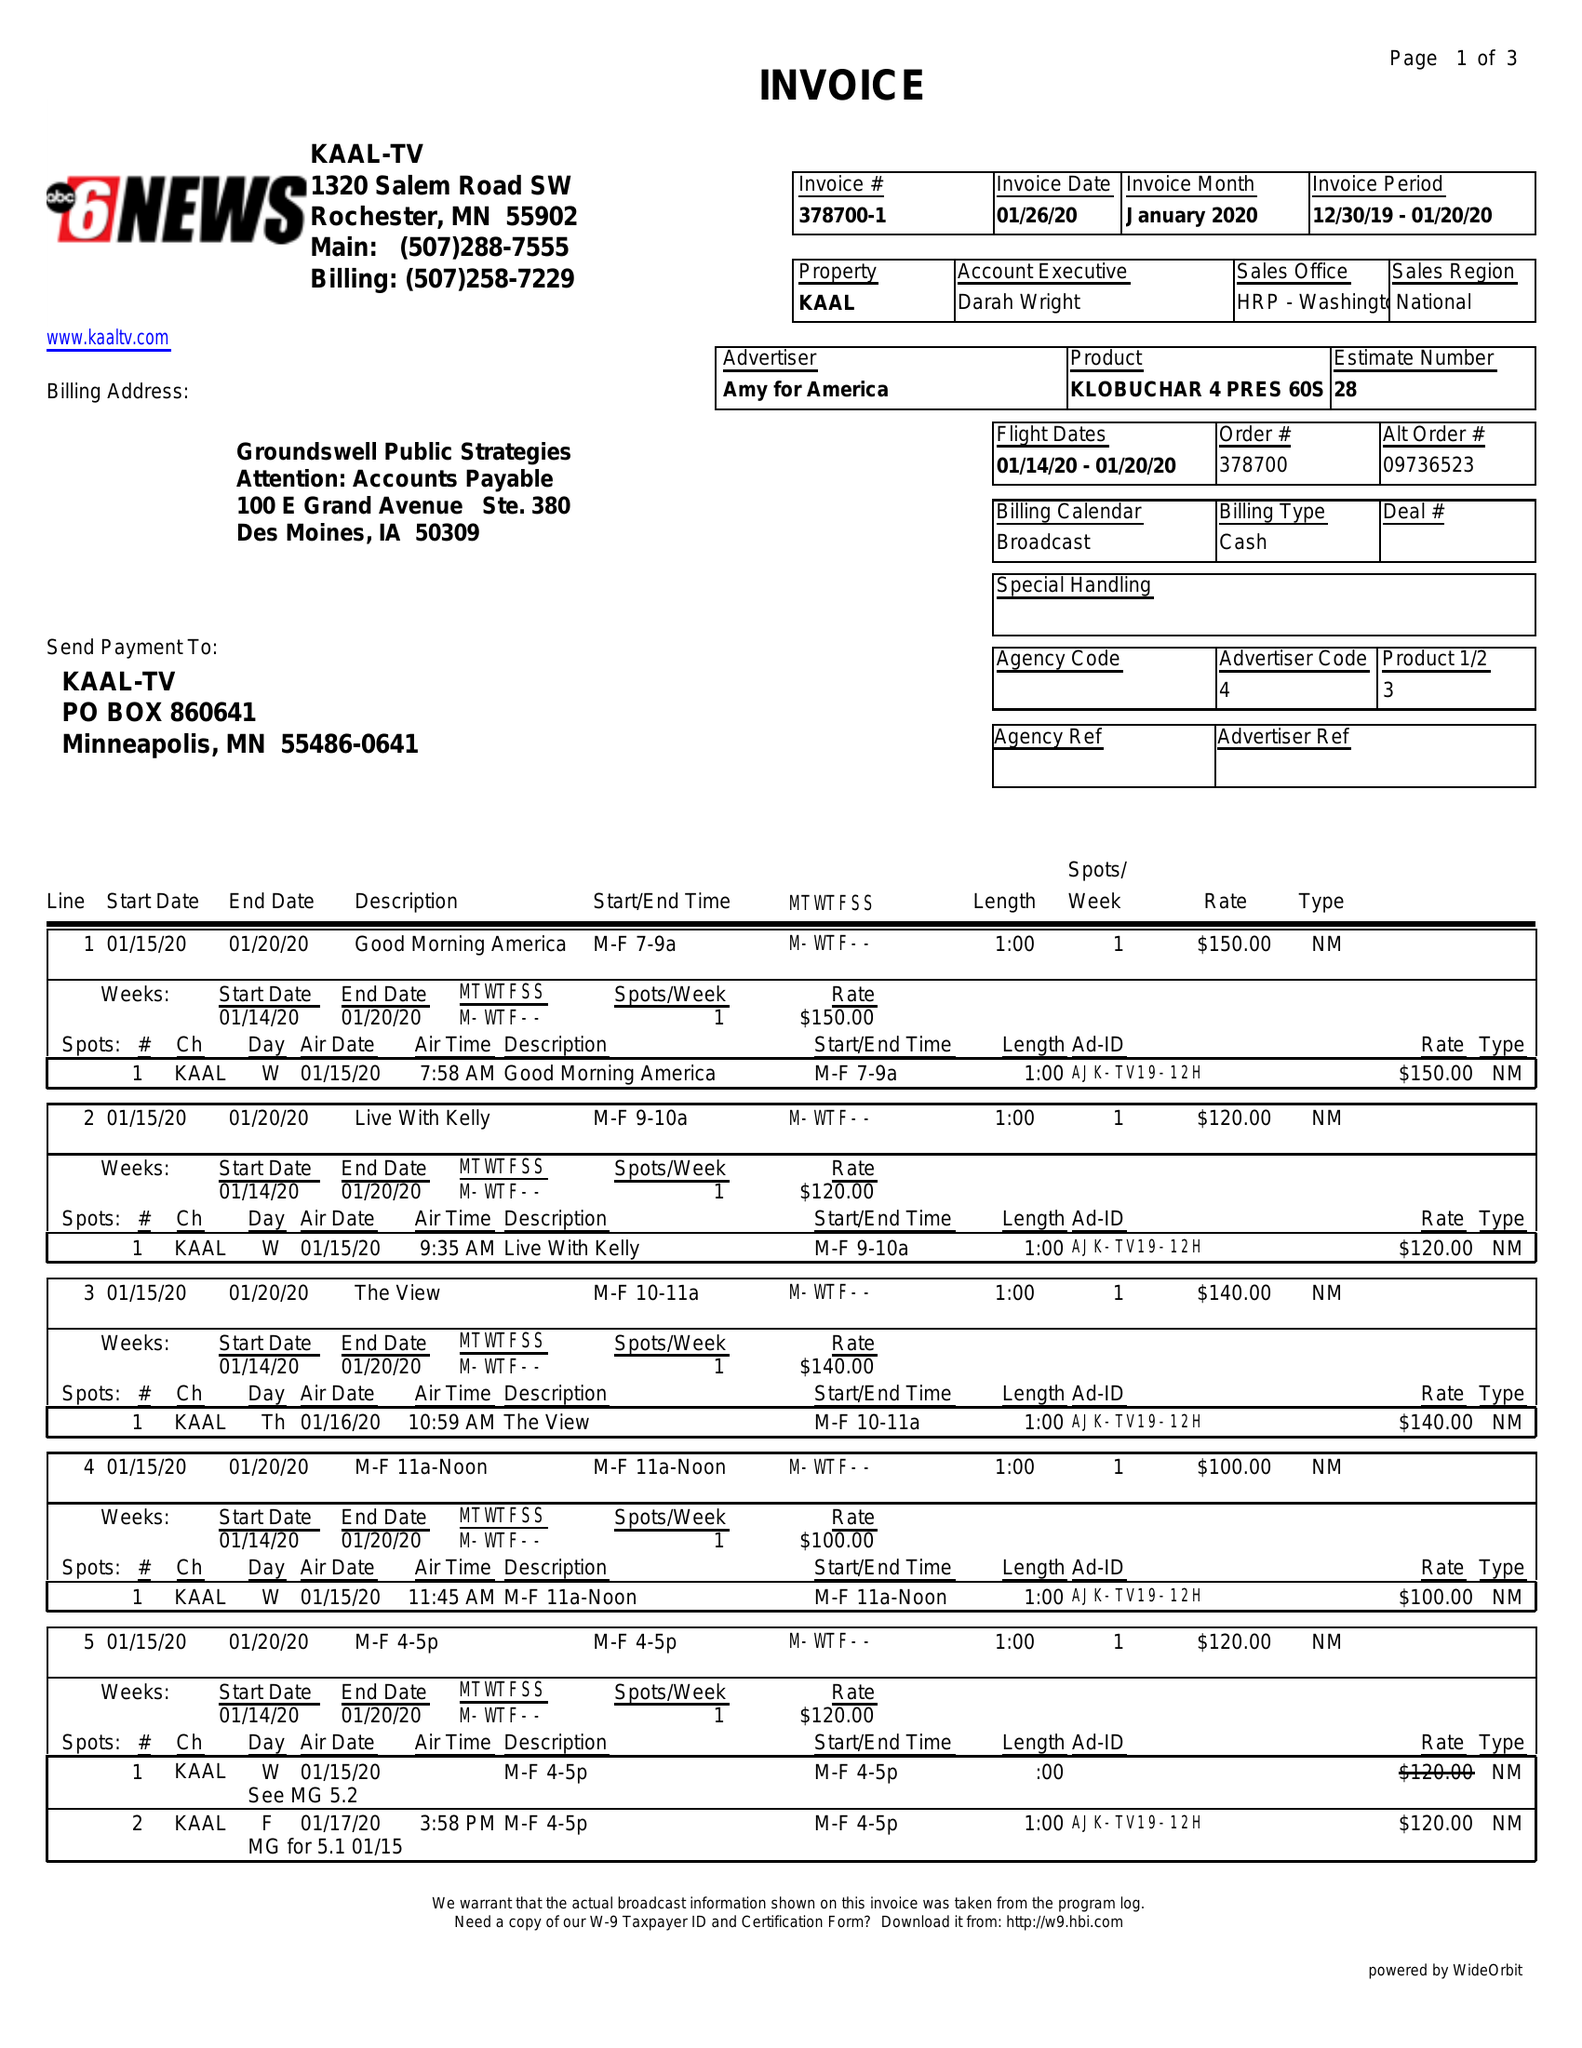What is the value for the gross_amount?
Answer the question using a single word or phrase. 4190.00 